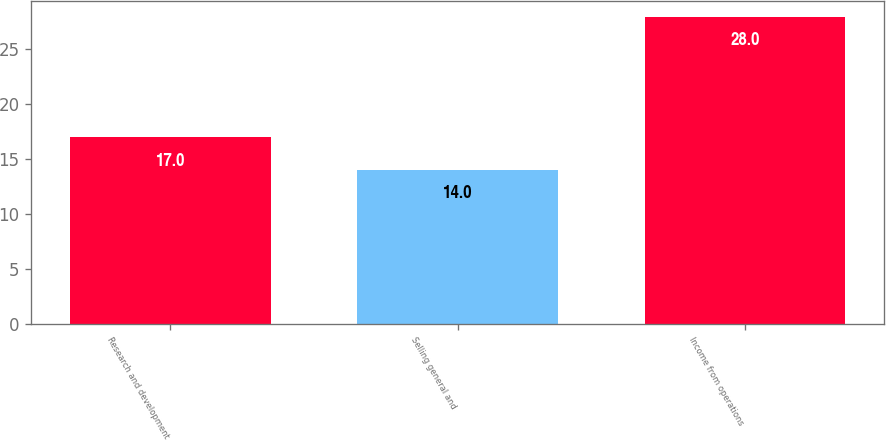<chart> <loc_0><loc_0><loc_500><loc_500><bar_chart><fcel>Research and development<fcel>Selling general and<fcel>Income from operations<nl><fcel>17<fcel>14<fcel>28<nl></chart> 